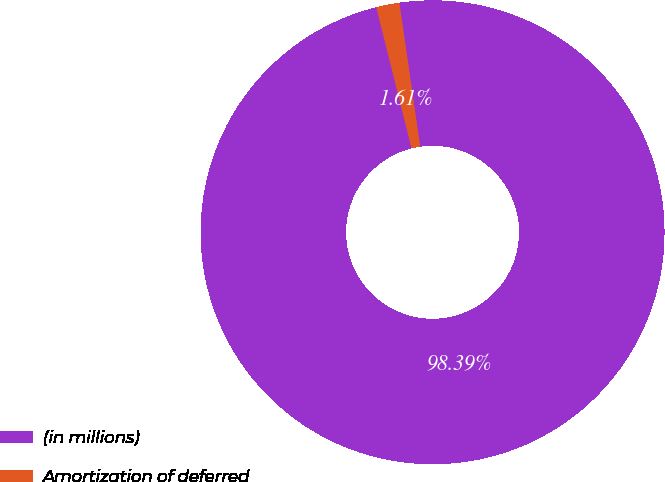Convert chart to OTSL. <chart><loc_0><loc_0><loc_500><loc_500><pie_chart><fcel>(in millions)<fcel>Amortization of deferred<nl><fcel>98.39%<fcel>1.61%<nl></chart> 